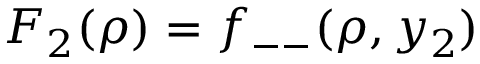Convert formula to latex. <formula><loc_0><loc_0><loc_500><loc_500>F _ { 2 } ( \rho ) = f _ { - - } ( \rho , y _ { 2 } )</formula> 